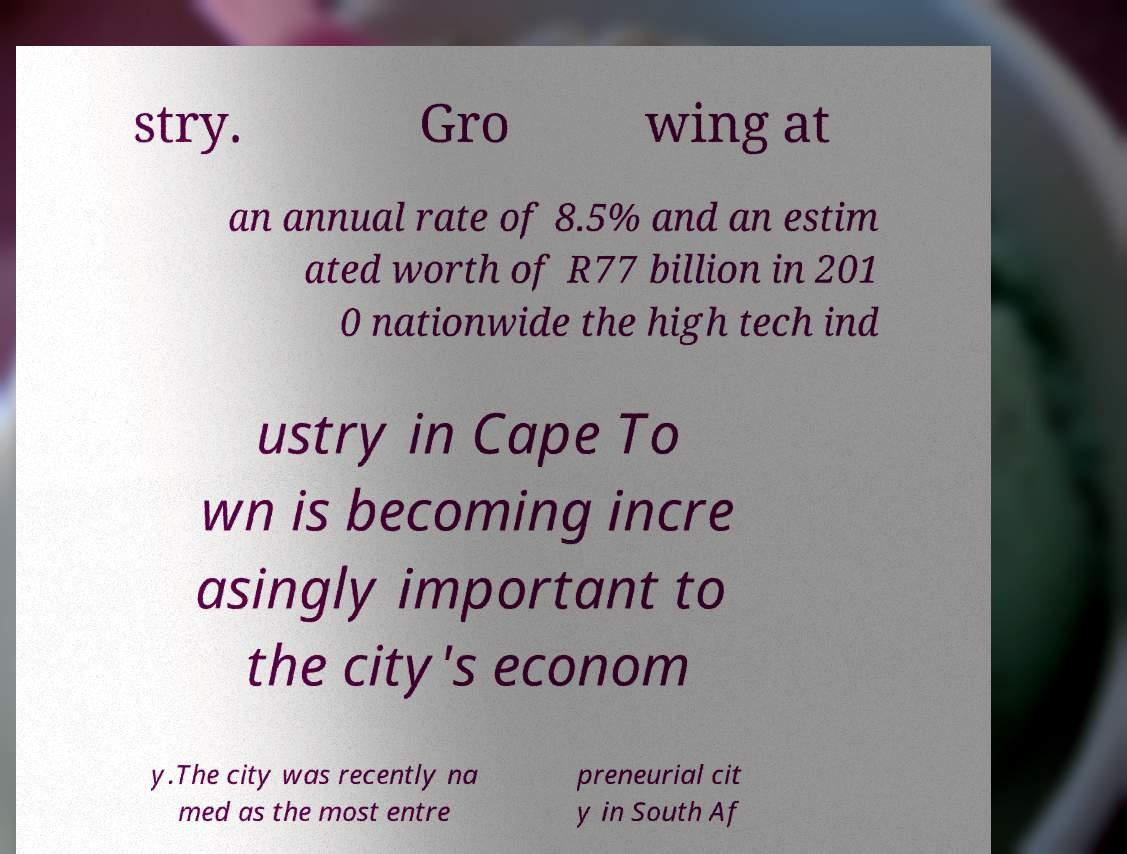What messages or text are displayed in this image? I need them in a readable, typed format. stry. Gro wing at an annual rate of 8.5% and an estim ated worth of R77 billion in 201 0 nationwide the high tech ind ustry in Cape To wn is becoming incre asingly important to the city's econom y.The city was recently na med as the most entre preneurial cit y in South Af 